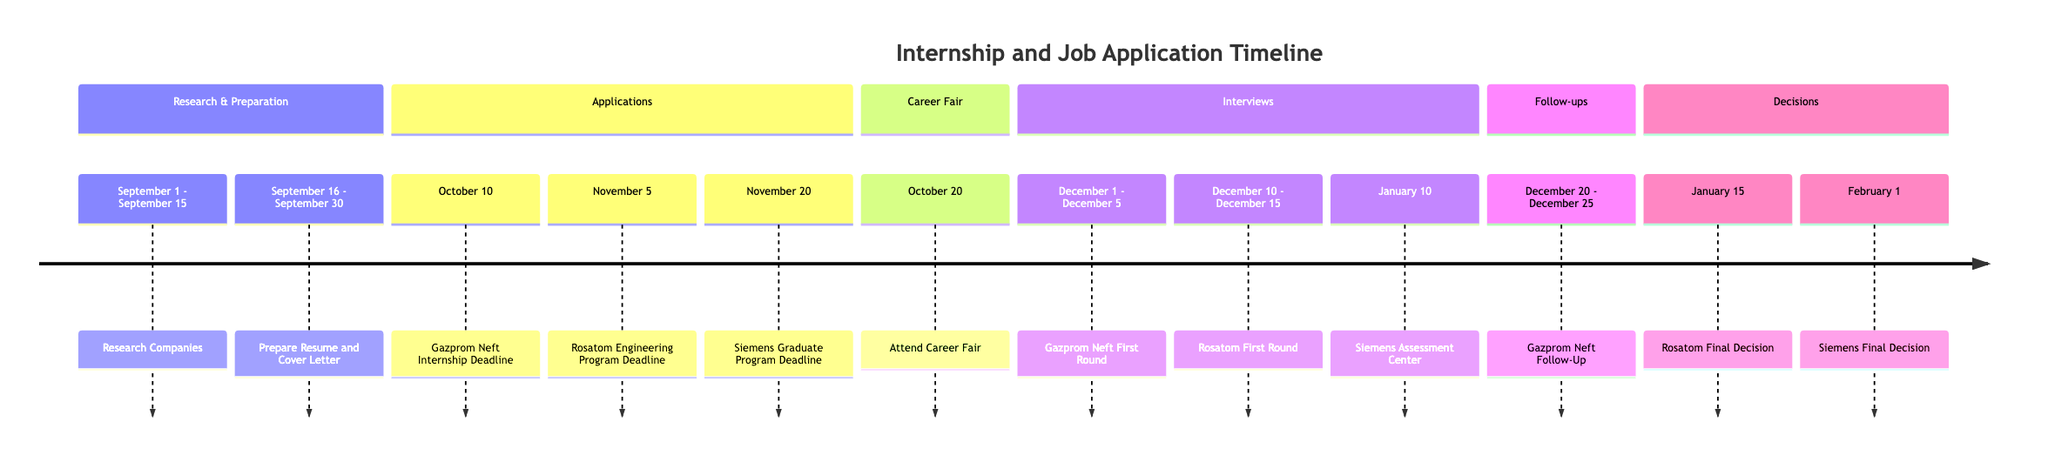What is the date range for preparing the resume and cover letter? The timeline indicates that preparing the resume and cover letter takes place from September 16 to September 30. This can be found in the "Prepare Resume and Cover Letter" section, which specifies its date range directly.
Answer: September 16 - September 30 How many application deadlines are listed in the timeline? By counting the specific application deadlines mentioned for Gazprom Neft, Rosatom, and Siemens, there are three distinct deadlines stated in the "Applications" section.
Answer: 3 What is the expected decision date for the Siemens Graduate Program? The timeline indicates that the final decision for the Siemens Graduate Program is expected on February 1. This is indicated under the "Decisions" section, specifying the date directly.
Answer: February 1 Which internship program has an application deadline earlier than Rosatom? Looking at the "Applications" section, the Gazprom Neft Internship deadline is on October 10, which is earlier than Rosatom's application deadline on November 5. Therefore, Gazprom Neft is the correct program.
Answer: Gazprom Neft Internship What action happens on January 10? The timeline indicates that January 10 is the date of the "Assessment Center Day" for the Siemens Graduate Program where participants will engage in group activities and interviews. This is referenced under the "Interviews" section.
Answer: Assessment Center Day What follow-up actions are planned after the Gazprom Neft Internship interviews? The timeline depicts that follow-up actions are scheduled from December 20 to December 25. The specific actions include checking application status and sending a follow-up email which is detailed in the "Follow-ups" section.
Answer: Check application status, send follow-up email Who is responsible for sending thank you emails? The timeline states that sending thank you emails occurs one day after each interview. This indicates the responsibility falls on the interviewee to express gratitude after interviews have taken place.
Answer: The interviewee What is the duration of the first round interviews for Rosatom Engineering Program? The first round interviews for the Rosatom Engineering Program are set to take place between December 10 and December 15, meaning the duration covers 6 days as specified in the timeline.
Answer: December 10 - December 15 What two documents are required for the Rosatom Engineering Program application? According to the timeline, applicants need to attach academic transcripts and include two recommendation letters when submitting their application for the Rosatom Engineering Program. This is mentioned in the corresponding deadline section.
Answer: Academic transcripts, two recommendation letters 